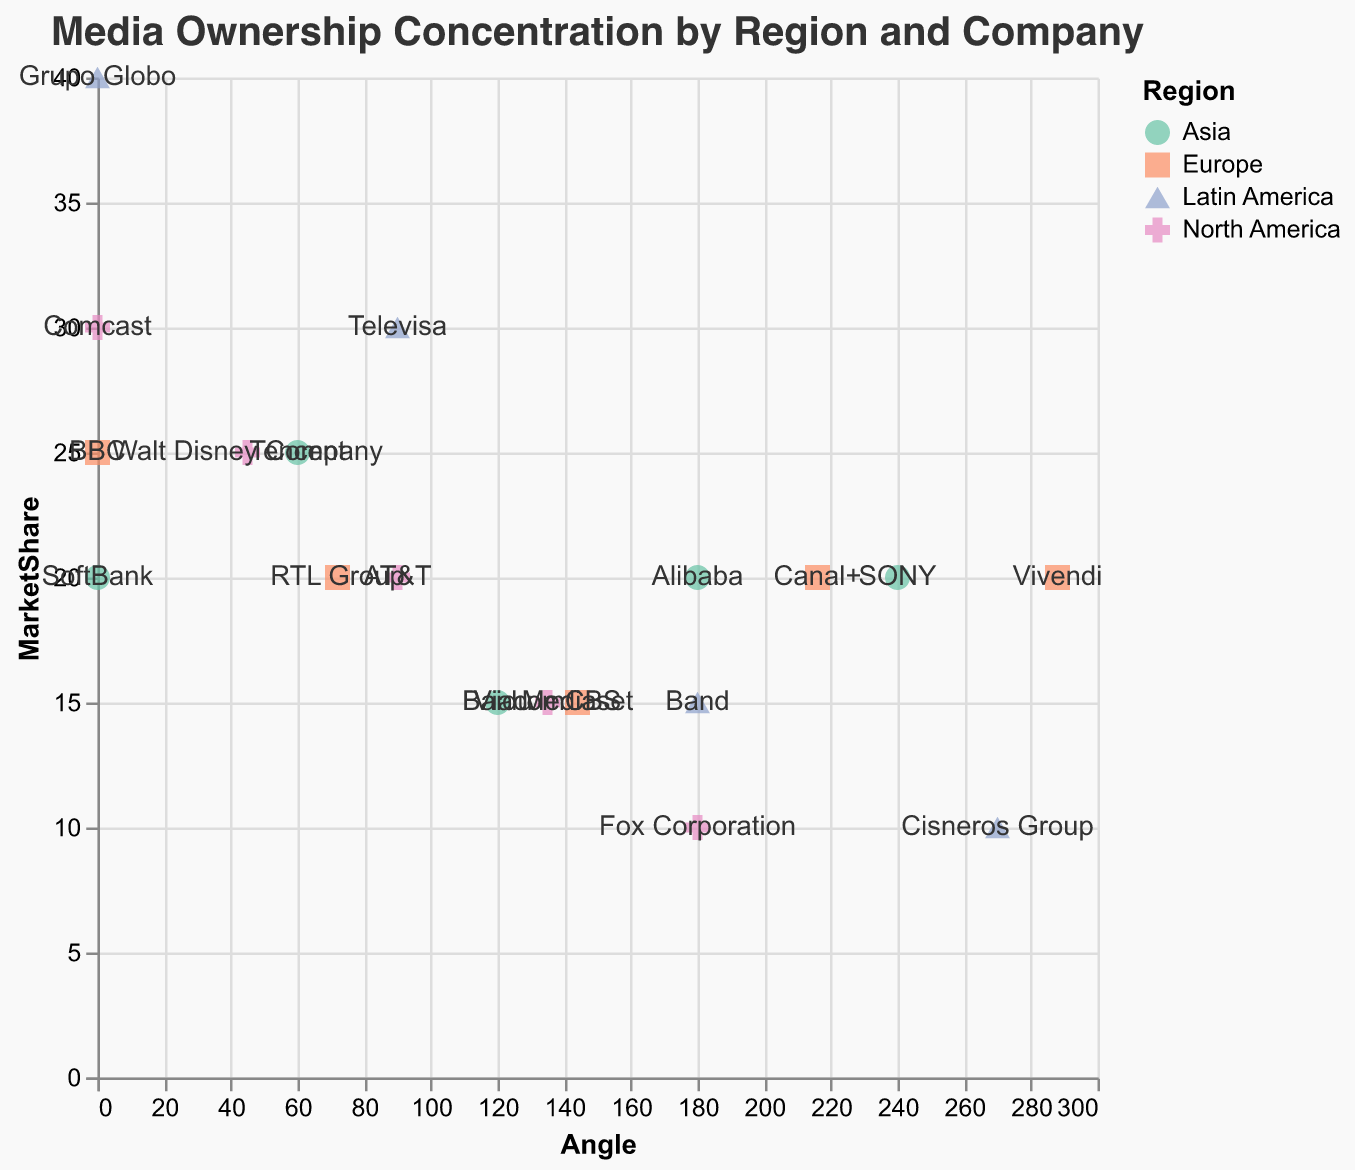what is the title of the figure? The title is usually found at the top of the figure and is an overview or subject matter of the chart.
Answer: Media Ownership Concentration by Region and Company Which company has the highest market share in North America? To find this, look for data points labeled with companies in North America and identify the one with the highest numerical market share. Comcast has the highest share at 30%.
Answer: Comcast Which region has the company with the largest market share? Examine each region to find the company with the largest market share. Grupo Globo from Latin America has the highest with 40%.
Answer: Latin America What is the combined market share of "RTL Group" and "Canal+" in Europe? Add the market shares of RTL Group and Canal+, which are 20% and 20% respectively. 20 + 20 = 40%.
Answer: 40% Which company in Asia has the smallest market share and what is its value? Check the data points for Asia and identify the company with the smallest numerical market share. Baidu has the smallest market share with 15%.
Answer: Baidu, 15% How many companies in Europe have a market share of 20% or higher? Identify the European companies and count how many have a market share of 20% or higher. BBC, RTL Group, Canal+, and Vivendi all have 20% or higher, totaling 4 companies.
Answer: 4 Is there any region where all companies have different market shares? Check the data for each region to see if all companies within a single region have unique market shares. In Latin America, all companies have different market shares: 40%, 30%, 15%, 10%.
Answer: Yes, in Latin America What is the average market share of companies in Asia? Sum up the market shares of all companies in Asia and divide by the number of companies. (20 + 25 + 15 + 20 + 20) / 5 = 20%.
Answer: 20% Which company has a market share of 25% and in which regions are they located? Identify the companies with a market share of 25% and find their associated regions. Walt Disney Company in North America, BBC in Europe, and Tencent in Asia.
Answer: Walt Disney Company (North America), BBC (Europe), Tencent (Asia) Comparing North America and Europe, which region has greater media market share and by how much? Sum the market shares of companies in each region and compare them. North America: 30 + 25 + 20 + 15 + 10 = 100, Europe: 25 + 20 + 15 + 20 + 20 = 100. Both are equal.
Answer: Both regions have equal market shares of 100% 